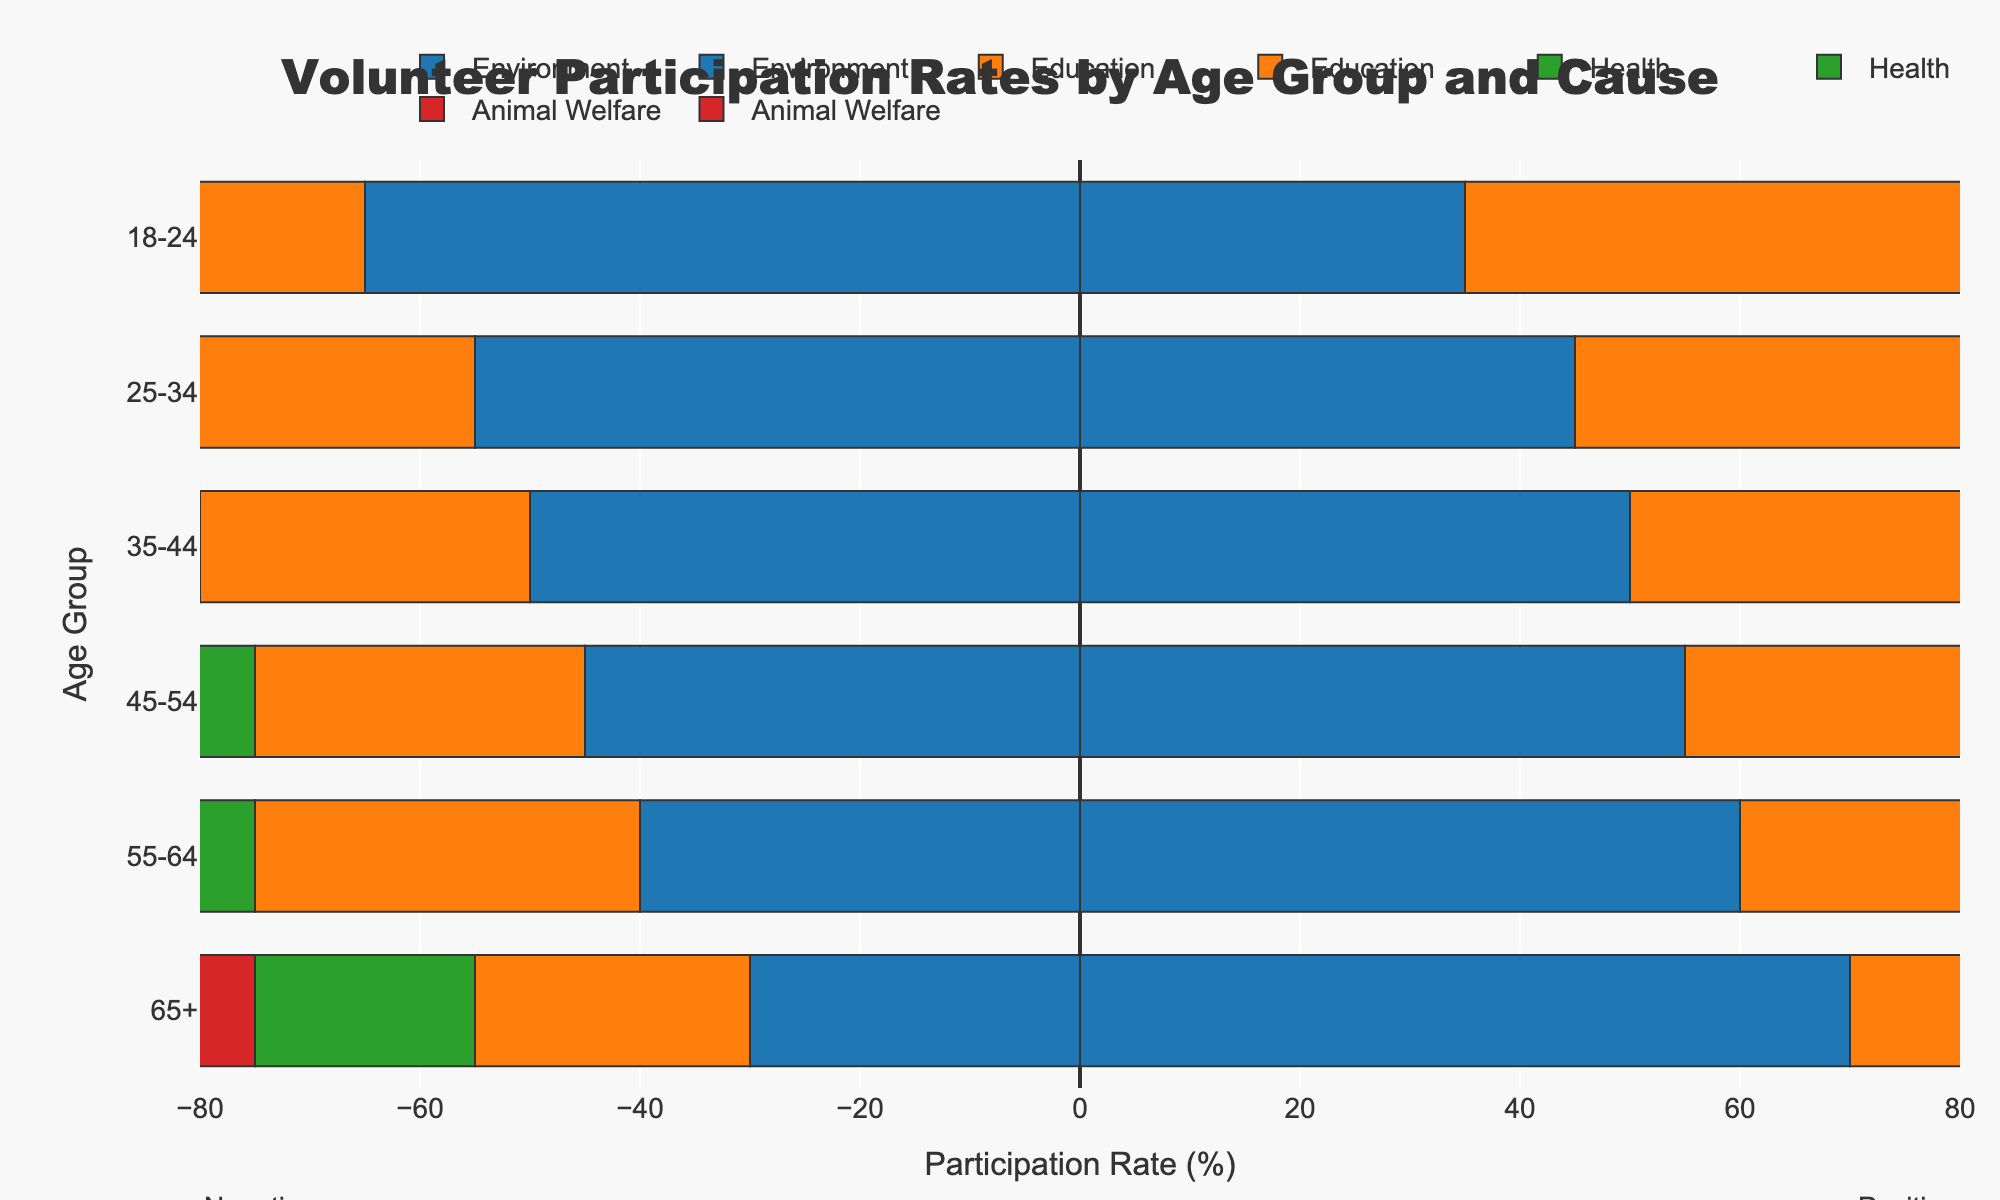What age group has the highest positive volunteer participation rate for Health? To determine which age group has the highest positive volunteer participation rate for Health, look at the bars corresponding to Health and check the positive ends. The 65+ age group has the highest positive bar extending to 80%.
Answer: 65+ Which cause has the most support from 18-24 age group? Compare the positive sides of the bars for each cause in the 18-24 age group. Education has the highest positive rate at 55%.
Answer: Education What is the difference between positive and negative rates for Education in the 35-44 age group? Find the positive and negative rates for Education in the 35-44 age group. The positive rate is 70%, and the negative rate is 30%. The difference is 70 - 30 = 40.
Answer: 40 Which age group has the lowest overall positive participation across all causes? For each age group, sum the positive rates for all causes and compare. The 18-24 age group has the positive rates: 35 + 55 + 45 + 60 = 195, which is the lowest sum among all age groups.
Answer: 18-24 Does the positive participation rate in Environment cause increase or decrease with age? Check the positive bars for the Environment cause across different age groups: 18-24 (35%), 25-34 (45%), 35-44 (50%), 45-54 (55%), 55-64 (60%), 65+ (70%). The rate increases with age.
Answer: Increase What is the total positive participation rate for the 55-64 age group across all causes? Sum the positive participation rates for all causes in the 55-64 age group: Environment (60%), Education (65%), Health (70%), Animal Welfare (75%). Total = 60 + 65 + 70 + 75 = 270.
Answer: 270 Which cause has the least support from the 65+ age group? Compare the positive participation rates for the 65+ age group for each cause. Environment has the lowest positive rate at 70%.
Answer: Environment Is the highest negative participation rate for any cause higher than the highest positive participation rate for any cause? The highest negative participation rate is 65% for Environment in the 18-24 age group. The highest positive participation rate is 80% for Health in the 65+ age group. 65% (negative) is not higher than 80% (positive).
Answer: No In the 45-54 age group, which cause has a balance (equal) between positive and negative participation rates? Check each cause in the 45-54 age group to see if the positive rate equals the negative rate. None of the causes have an equal balance in this age group.
Answer: None Between the Education cause in the 25-34 age group and the Health cause in the 35-44 age group, which has a higher positive participation rate? Compare the positive rates: Education in 25-34 (65%) and Health in 35-44 (60%). Education in 25-34 has a higher positive participation rate.
Answer: Education in 25-34 